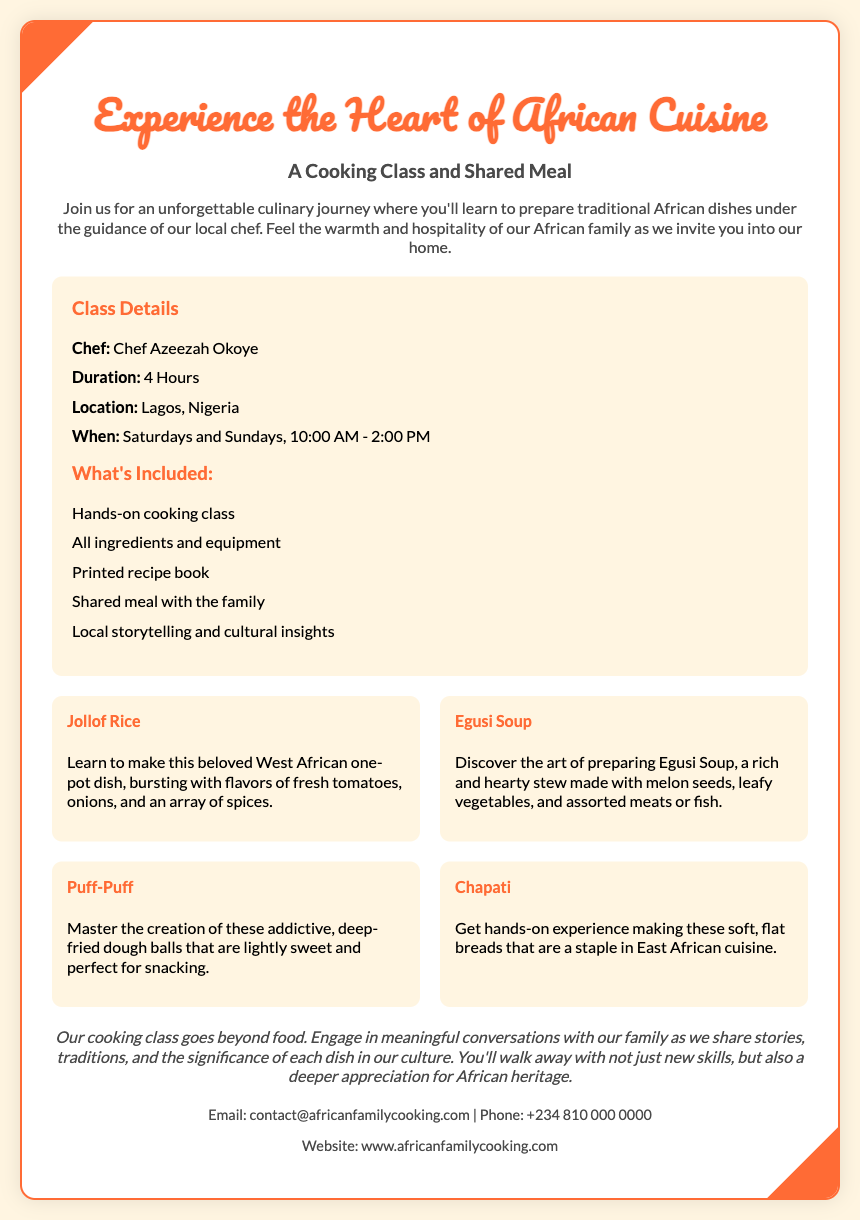What is the name of the chef? The chef's name is mentioned in the details section of the document.
Answer: Chef Azeezah Okoye What is the duration of the cooking class? The duration of the cooking class is specified in the class details.
Answer: 4 Hours What days of the week is the class offered? The days the class is available are listed under the "When" section.
Answer: Saturdays and Sundays What dish is made with melon seeds? This dish is highlighted in the list of traditional dishes included in the cooking class.
Answer: Egusi Soup What is included with the cooking class? The included items are listed in the "What's Included" section of the document.
Answer: Hands-on cooking class How many dishes are highlighted in the document? The number of highlighted dishes can be determined by counting the individual sections about each dish.
Answer: Four What cultural aspect does the class emphasize? The cultural significance is mentioned in the cultural insight section of the document.
Answer: Traditions and storytelling What type of cuisine will be explored in this class? The cuisine type is expressed in the title and content of the voucher.
Answer: African Cuisine 